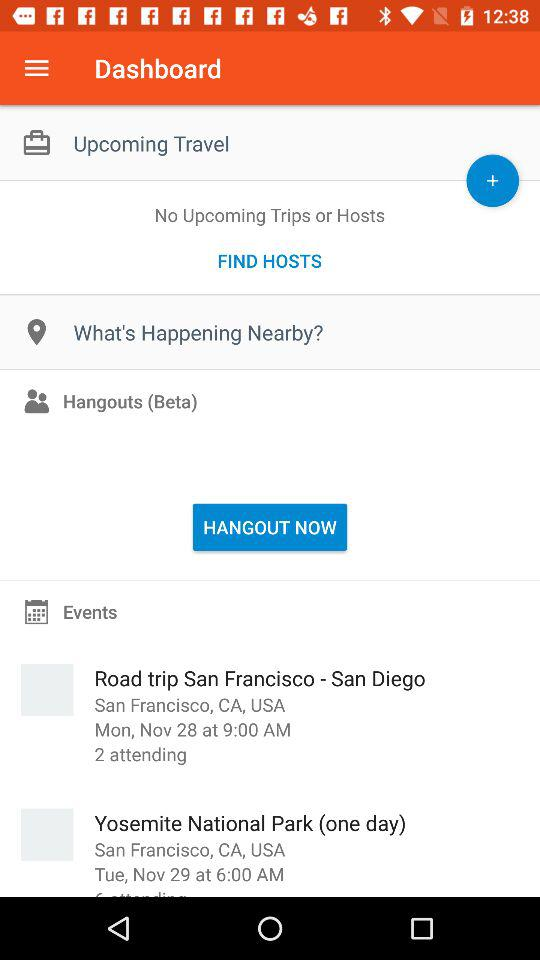What is the date and time of the "Road trip San Francisco - San Diego" event? The date and time of the "Road trip San Francisco - San Diego" event are Monday, November 28 at 9:00 AM. 